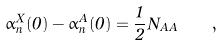Convert formula to latex. <formula><loc_0><loc_0><loc_500><loc_500>\alpha _ { n } ^ { X } ( 0 ) - \alpha _ { n } ^ { A } ( 0 ) = \frac { 1 } { 2 } N _ { A A } \quad ,</formula> 